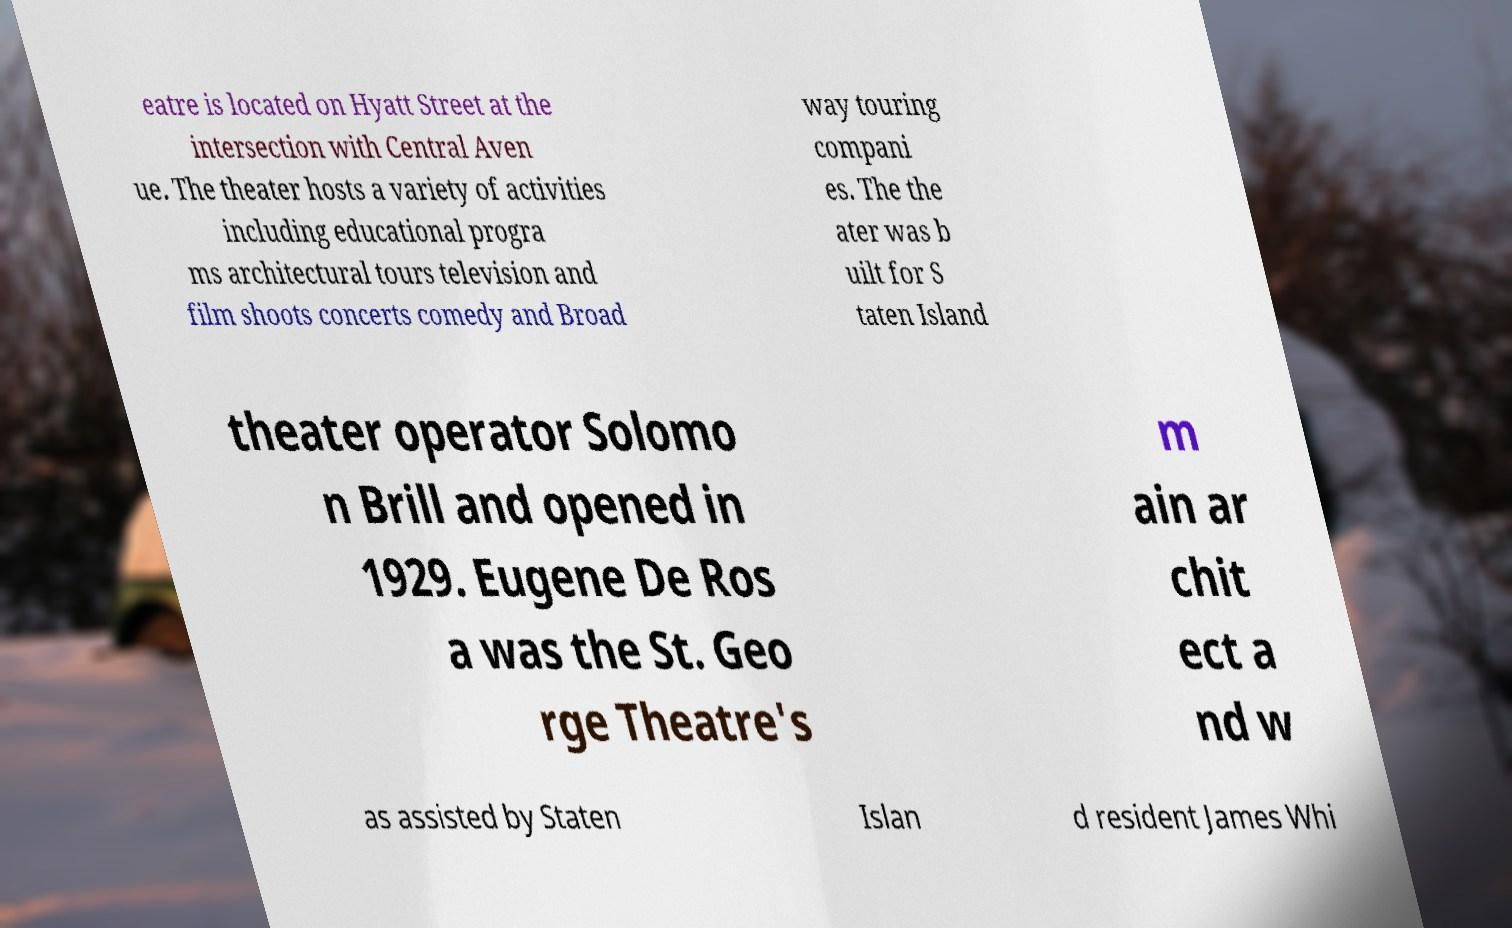Please read and relay the text visible in this image. What does it say? eatre is located on Hyatt Street at the intersection with Central Aven ue. The theater hosts a variety of activities including educational progra ms architectural tours television and film shoots concerts comedy and Broad way touring compani es. The the ater was b uilt for S taten Island theater operator Solomo n Brill and opened in 1929. Eugene De Ros a was the St. Geo rge Theatre's m ain ar chit ect a nd w as assisted by Staten Islan d resident James Whi 